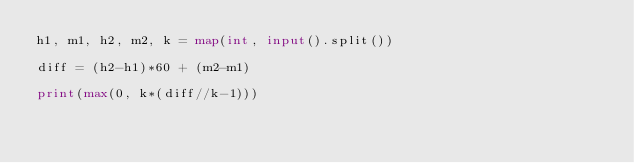<code> <loc_0><loc_0><loc_500><loc_500><_Python_>h1, m1, h2, m2, k = map(int, input().split())

diff = (h2-h1)*60 + (m2-m1)

print(max(0, k*(diff//k-1)))</code> 